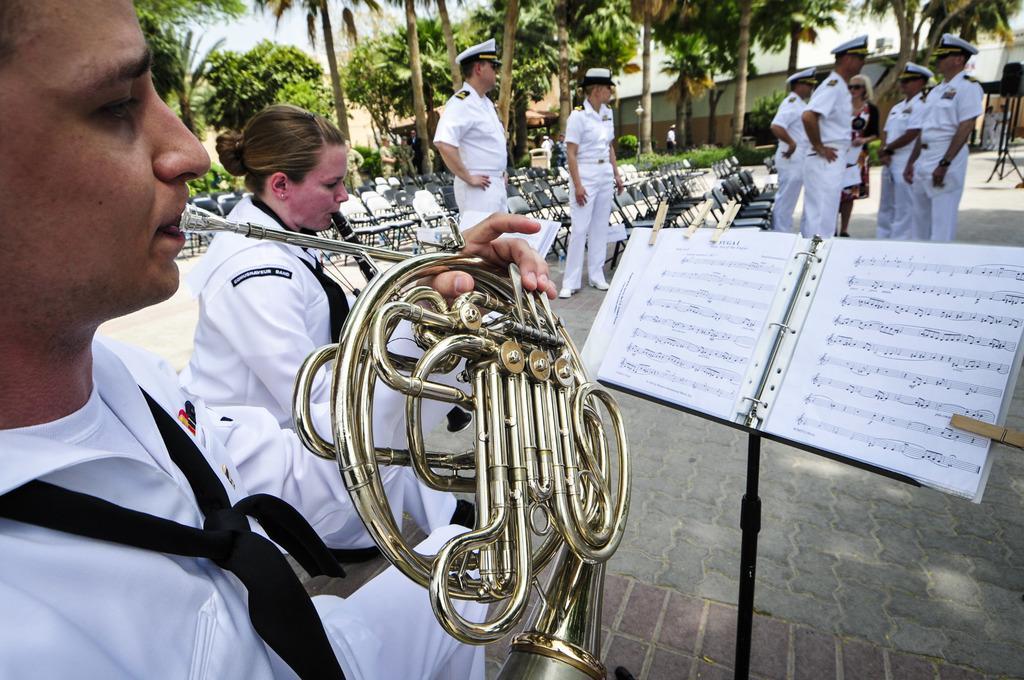Could you give a brief overview of what you see in this image? In this image there are two people standing and playing musical instruments looking at the music codes on the book which is on stand, beside them there are so many empty chairs and people standing also there are some trees and buildings. 